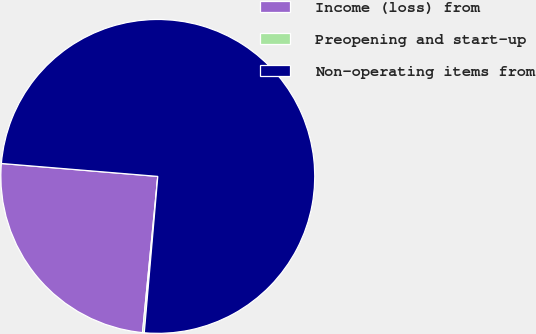Convert chart to OTSL. <chart><loc_0><loc_0><loc_500><loc_500><pie_chart><fcel>Income (loss) from<fcel>Preopening and start-up<fcel>Non-operating items from<nl><fcel>24.76%<fcel>0.18%<fcel>75.06%<nl></chart> 